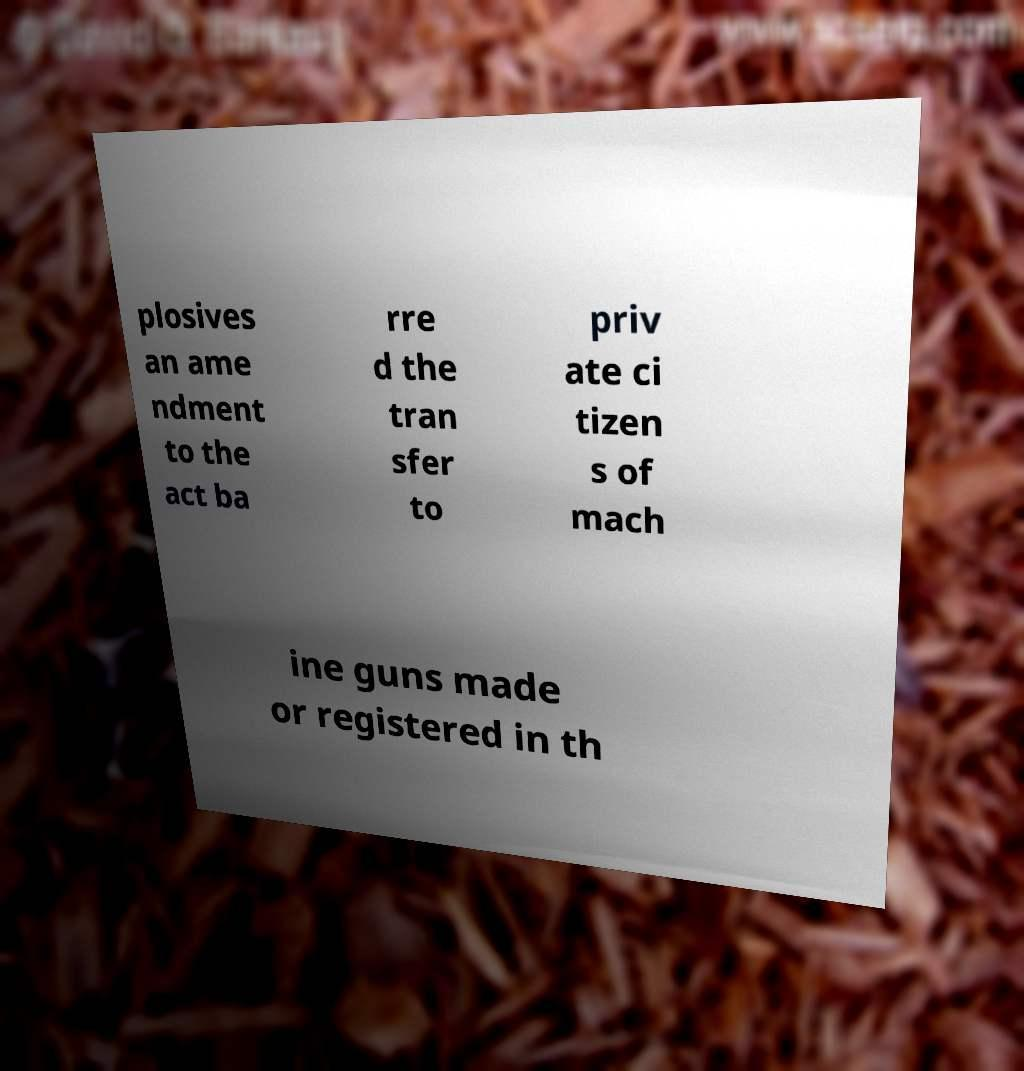Could you extract and type out the text from this image? plosives an ame ndment to the act ba rre d the tran sfer to priv ate ci tizen s of mach ine guns made or registered in th 